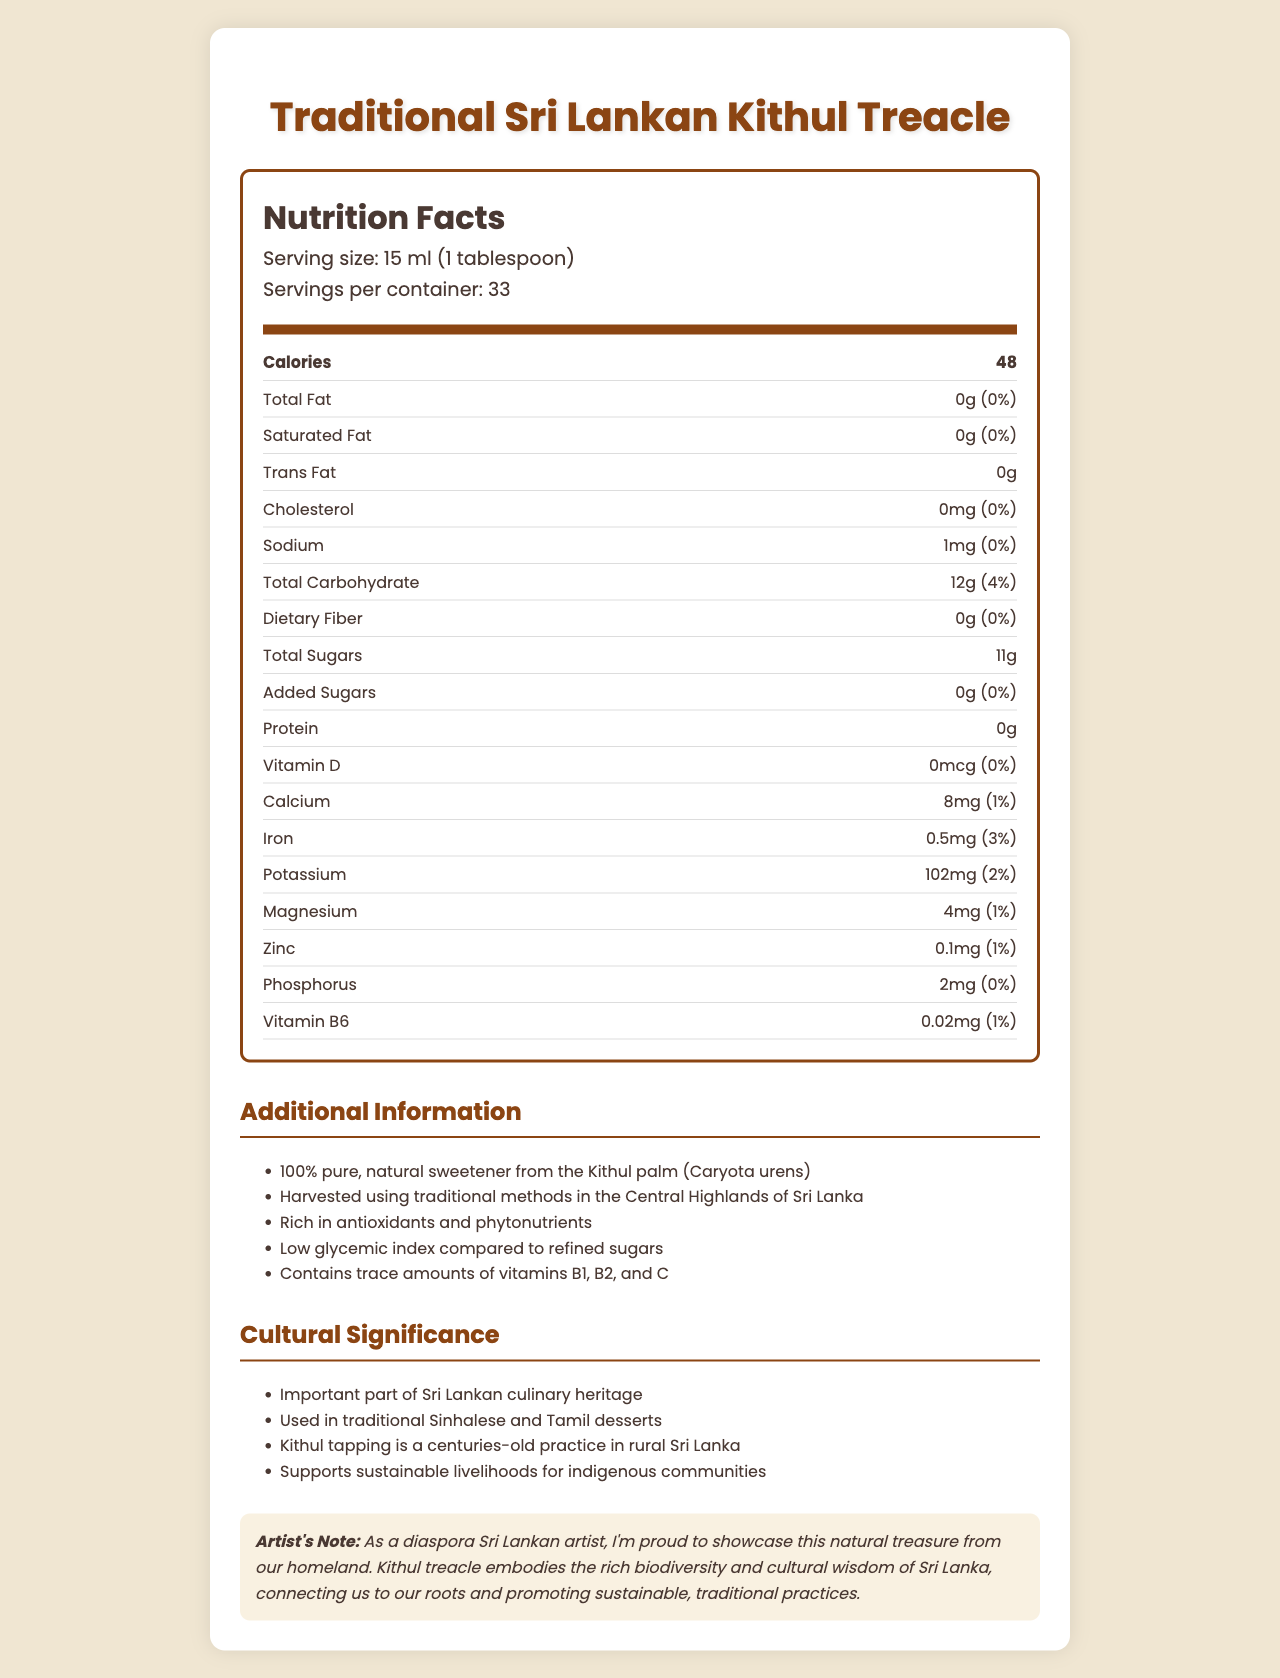what is the serving size for Traditional Sri Lankan Kithul Treacle? The serving size is specified as "15 ml (1 tablespoon)" in the serving info section.
Answer: 15 ml (1 tablespoon) how many calories are in one serving of Kithul Treacle? The calories per serving are listed as "48" in the nutrient row for calories.
Answer: 48 calories what is the amount of total sugars in one serving? The total sugars per serving are listed as "11g" in the nutrient row for Total Sugars.
Answer: 11g how much potassium is in one serving? The potassium content per serving is listed as "102mg" in the nutrient row for Potassium.
Answer: 102mg how much calcium is in one serving of Kithul Treacle? The amount of calcium per serving is specified as "8mg" in the nutrient row for Calcium.
Answer: 8mg what is the primary ingredient in Kithul Treacle? The additional information section states that the product is a "100% pure, natural sweetener from the Kithul palm (Caryota urens)."
Answer: 100% pure, natural sweetener from the Kithul palm (Caryota urens) what type of sweetener is Kithul Treacle? A. Artificial B. Natural C. Refined D. Synthetic The additional information section mentions that Kithul Treacle is a "100% pure, natural sweetener."
Answer: B which vitamins are present in trace amounts in Kithul Treacle? A. Vitamin A, Vitamin E, Vitamin K B. Vitamin B1, B2, C C. Vitamin D, Vitamin E, Vitamin K D. Vitamin A, Vitamin C, Vitamin E The additional information section states that Kithul Treacle contains trace amounts of "vitamins B1, B2, and C."
Answer: B does Kithul Treacle contain any added sugars? The nutrient row for Added Sugars shows "0g (0%)", indicating no added sugars.
Answer: No is Kithul Treacle a high glycemic index sweetener? The additional information section notes that Kithul Treacle has a "Low glycemic index compared to refined sugars."
Answer: No describe the main idea of the document. The document gives a comprehensive overview of the nutritional content of Kithul Treacle, its benefits as a natural sweetener, and its cultural and economic importance in Sri Lanka.
Answer: The document provides a detailed Nutrition Facts Label for Traditional Sri Lankan Kithul Treacle, highlighting its serving size, nutrient profile, and additional information about its natural sweetness, cultural significance, and traditional harvesting methods. what is the exact origin of the Kithul Treacle? The document mentions that Kithul Treacle is harvested using traditional methods in the Central Highlands of Sri Lanka, but it does not provide an exact geographical origin.
Answer: Cannot be determined 